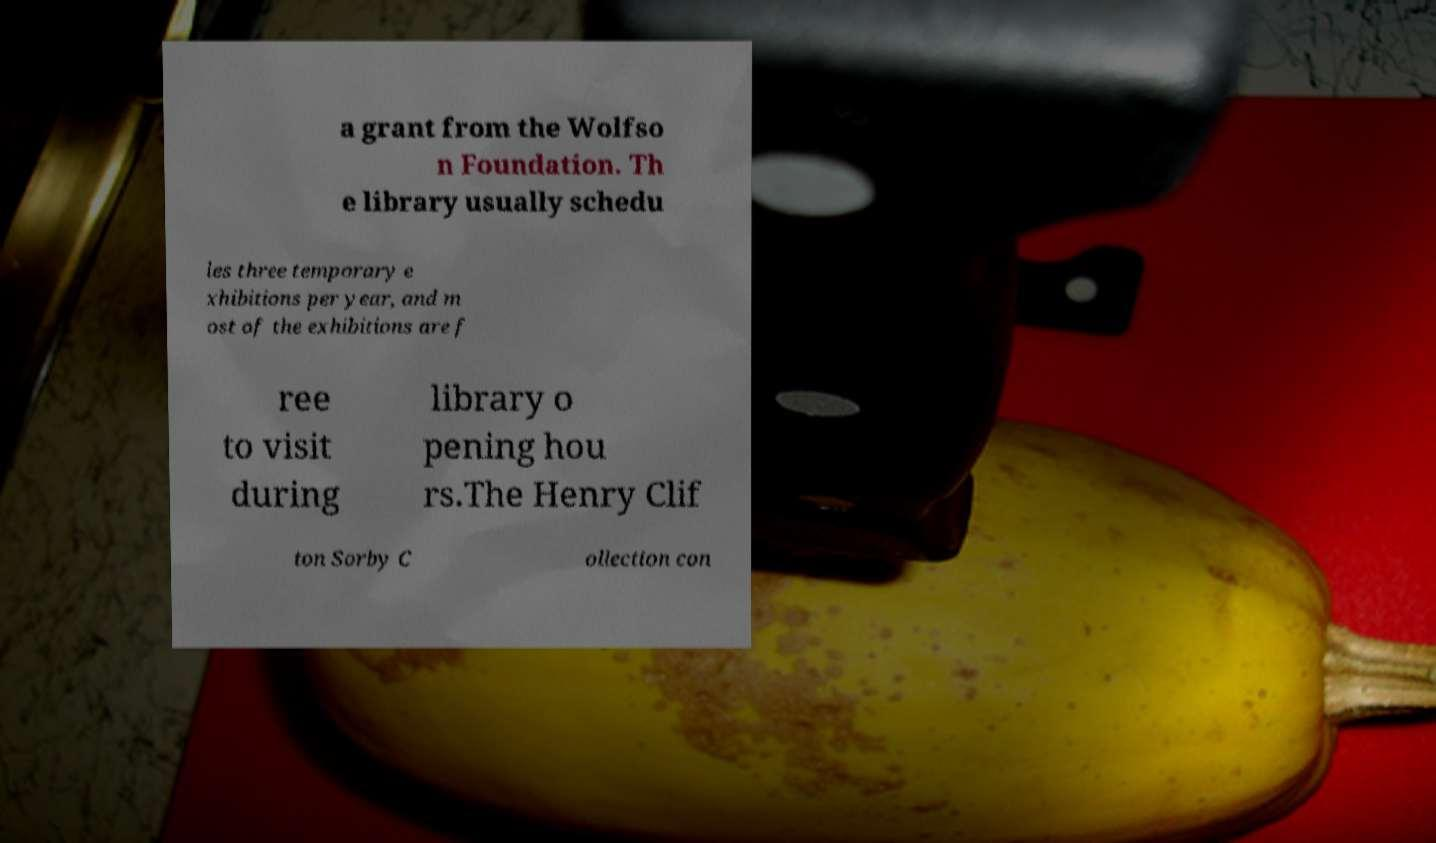Can you accurately transcribe the text from the provided image for me? a grant from the Wolfso n Foundation. Th e library usually schedu les three temporary e xhibitions per year, and m ost of the exhibitions are f ree to visit during library o pening hou rs.The Henry Clif ton Sorby C ollection con 